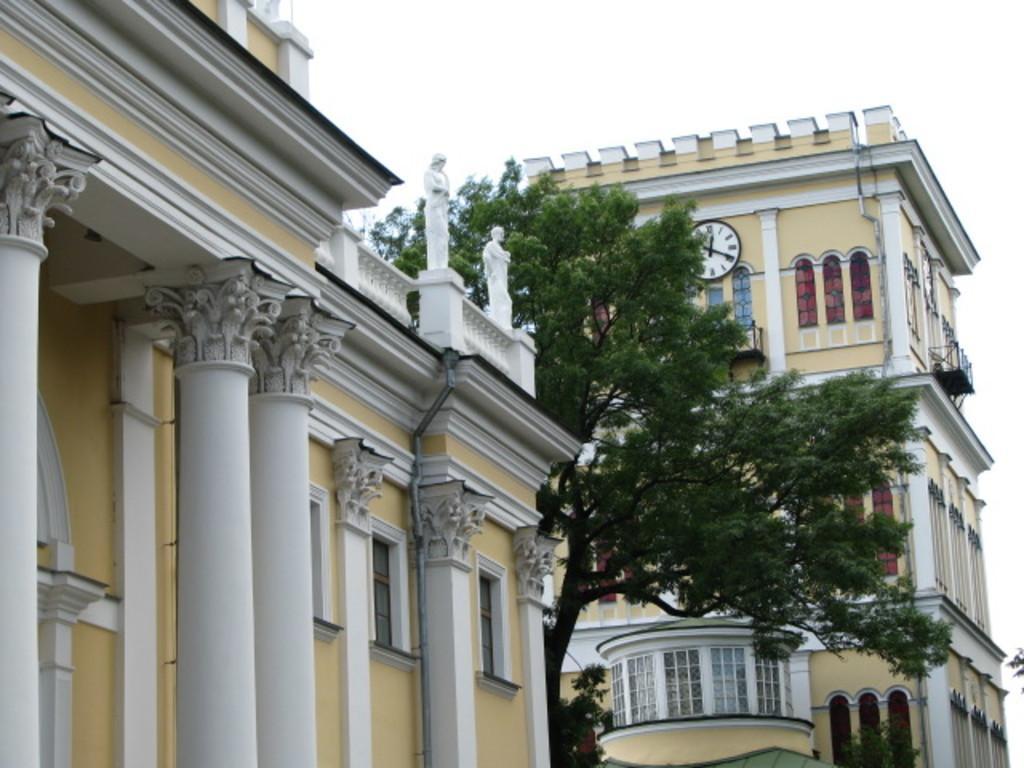In one or two sentences, can you explain what this image depicts? In this image we can see the buildings and also tree, clock and sculptures. We can also see the sky. 